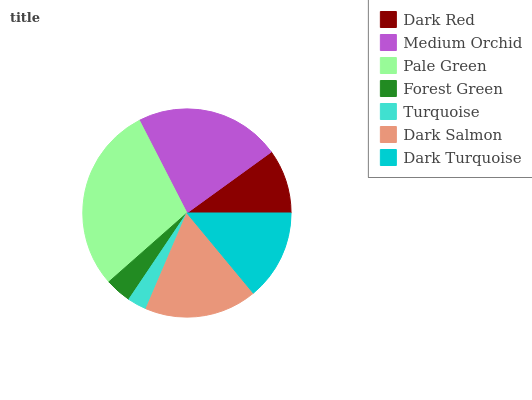Is Turquoise the minimum?
Answer yes or no. Yes. Is Pale Green the maximum?
Answer yes or no. Yes. Is Medium Orchid the minimum?
Answer yes or no. No. Is Medium Orchid the maximum?
Answer yes or no. No. Is Medium Orchid greater than Dark Red?
Answer yes or no. Yes. Is Dark Red less than Medium Orchid?
Answer yes or no. Yes. Is Dark Red greater than Medium Orchid?
Answer yes or no. No. Is Medium Orchid less than Dark Red?
Answer yes or no. No. Is Dark Turquoise the high median?
Answer yes or no. Yes. Is Dark Turquoise the low median?
Answer yes or no. Yes. Is Forest Green the high median?
Answer yes or no. No. Is Pale Green the low median?
Answer yes or no. No. 